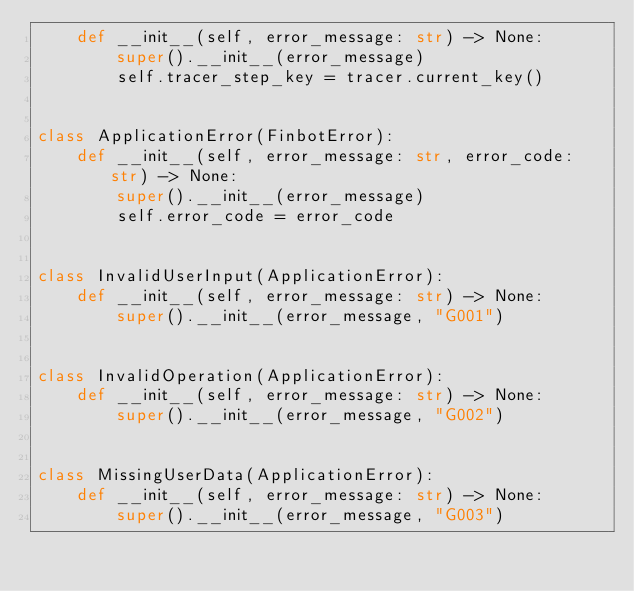Convert code to text. <code><loc_0><loc_0><loc_500><loc_500><_Python_>    def __init__(self, error_message: str) -> None:
        super().__init__(error_message)
        self.tracer_step_key = tracer.current_key()


class ApplicationError(FinbotError):
    def __init__(self, error_message: str, error_code: str) -> None:
        super().__init__(error_message)
        self.error_code = error_code


class InvalidUserInput(ApplicationError):
    def __init__(self, error_message: str) -> None:
        super().__init__(error_message, "G001")


class InvalidOperation(ApplicationError):
    def __init__(self, error_message: str) -> None:
        super().__init__(error_message, "G002")


class MissingUserData(ApplicationError):
    def __init__(self, error_message: str) -> None:
        super().__init__(error_message, "G003")
</code> 